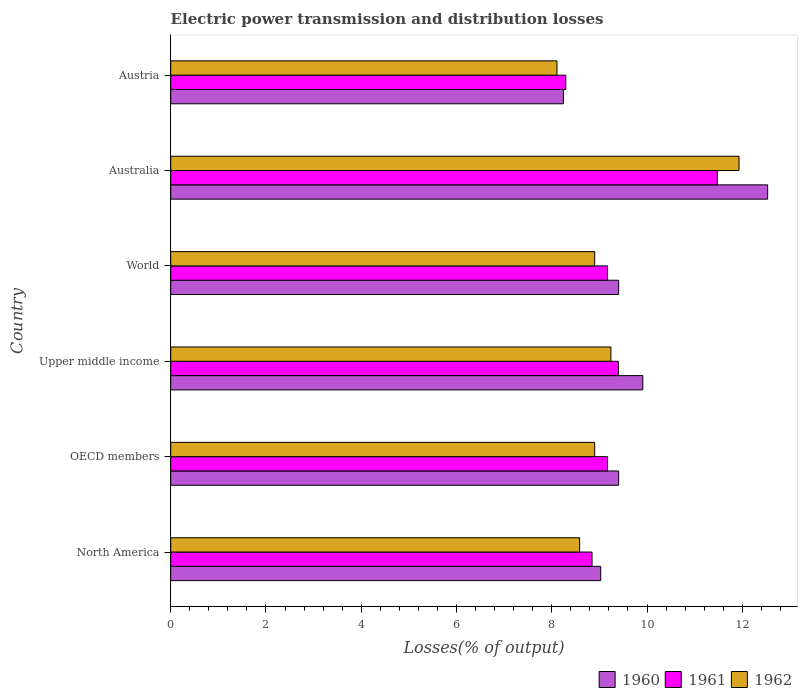Are the number of bars on each tick of the Y-axis equal?
Your response must be concise. Yes. How many bars are there on the 2nd tick from the top?
Make the answer very short. 3. How many bars are there on the 6th tick from the bottom?
Give a very brief answer. 3. What is the label of the 1st group of bars from the top?
Offer a terse response. Austria. What is the electric power transmission and distribution losses in 1961 in World?
Provide a short and direct response. 9.17. Across all countries, what is the maximum electric power transmission and distribution losses in 1961?
Provide a short and direct response. 11.48. Across all countries, what is the minimum electric power transmission and distribution losses in 1961?
Provide a short and direct response. 8.3. In which country was the electric power transmission and distribution losses in 1962 maximum?
Provide a succinct answer. Australia. In which country was the electric power transmission and distribution losses in 1960 minimum?
Ensure brevity in your answer.  Austria. What is the total electric power transmission and distribution losses in 1960 in the graph?
Provide a short and direct response. 58.52. What is the difference between the electric power transmission and distribution losses in 1960 in Austria and that in Upper middle income?
Ensure brevity in your answer.  -1.67. What is the difference between the electric power transmission and distribution losses in 1960 in Australia and the electric power transmission and distribution losses in 1961 in Austria?
Your answer should be very brief. 4.24. What is the average electric power transmission and distribution losses in 1962 per country?
Offer a very short reply. 9.28. What is the difference between the electric power transmission and distribution losses in 1962 and electric power transmission and distribution losses in 1961 in Austria?
Provide a succinct answer. -0.19. What is the ratio of the electric power transmission and distribution losses in 1961 in Australia to that in Austria?
Keep it short and to the point. 1.38. Is the difference between the electric power transmission and distribution losses in 1962 in Austria and OECD members greater than the difference between the electric power transmission and distribution losses in 1961 in Austria and OECD members?
Offer a terse response. Yes. What is the difference between the highest and the second highest electric power transmission and distribution losses in 1960?
Your response must be concise. 2.62. What is the difference between the highest and the lowest electric power transmission and distribution losses in 1962?
Offer a terse response. 3.82. Is the sum of the electric power transmission and distribution losses in 1962 in Australia and OECD members greater than the maximum electric power transmission and distribution losses in 1961 across all countries?
Provide a succinct answer. Yes. What does the 1st bar from the top in North America represents?
Your response must be concise. 1962. Does the graph contain any zero values?
Your response must be concise. No. Where does the legend appear in the graph?
Ensure brevity in your answer.  Bottom right. How many legend labels are there?
Offer a very short reply. 3. What is the title of the graph?
Keep it short and to the point. Electric power transmission and distribution losses. Does "1982" appear as one of the legend labels in the graph?
Make the answer very short. No. What is the label or title of the X-axis?
Give a very brief answer. Losses(% of output). What is the label or title of the Y-axis?
Your answer should be compact. Country. What is the Losses(% of output) in 1960 in North America?
Your answer should be very brief. 9.03. What is the Losses(% of output) in 1961 in North America?
Ensure brevity in your answer.  8.85. What is the Losses(% of output) in 1962 in North America?
Offer a terse response. 8.59. What is the Losses(% of output) of 1960 in OECD members?
Provide a short and direct response. 9.4. What is the Losses(% of output) of 1961 in OECD members?
Provide a short and direct response. 9.17. What is the Losses(% of output) of 1962 in OECD members?
Your response must be concise. 8.9. What is the Losses(% of output) in 1960 in Upper middle income?
Provide a short and direct response. 9.91. What is the Losses(% of output) of 1961 in Upper middle income?
Offer a very short reply. 9.4. What is the Losses(% of output) in 1962 in Upper middle income?
Give a very brief answer. 9.24. What is the Losses(% of output) in 1960 in World?
Provide a succinct answer. 9.4. What is the Losses(% of output) in 1961 in World?
Your answer should be compact. 9.17. What is the Losses(% of output) in 1962 in World?
Provide a short and direct response. 8.9. What is the Losses(% of output) in 1960 in Australia?
Provide a succinct answer. 12.53. What is the Losses(% of output) in 1961 in Australia?
Provide a succinct answer. 11.48. What is the Losses(% of output) of 1962 in Australia?
Ensure brevity in your answer.  11.93. What is the Losses(% of output) in 1960 in Austria?
Your answer should be very brief. 8.24. What is the Losses(% of output) in 1961 in Austria?
Give a very brief answer. 8.3. What is the Losses(% of output) in 1962 in Austria?
Offer a very short reply. 8.11. Across all countries, what is the maximum Losses(% of output) in 1960?
Provide a succinct answer. 12.53. Across all countries, what is the maximum Losses(% of output) in 1961?
Offer a terse response. 11.48. Across all countries, what is the maximum Losses(% of output) in 1962?
Keep it short and to the point. 11.93. Across all countries, what is the minimum Losses(% of output) in 1960?
Your answer should be very brief. 8.24. Across all countries, what is the minimum Losses(% of output) in 1961?
Your response must be concise. 8.3. Across all countries, what is the minimum Losses(% of output) of 1962?
Your response must be concise. 8.11. What is the total Losses(% of output) in 1960 in the graph?
Provide a short and direct response. 58.52. What is the total Losses(% of output) of 1961 in the graph?
Your answer should be compact. 56.36. What is the total Losses(% of output) in 1962 in the graph?
Your answer should be very brief. 55.67. What is the difference between the Losses(% of output) of 1960 in North America and that in OECD members?
Give a very brief answer. -0.38. What is the difference between the Losses(% of output) in 1961 in North America and that in OECD members?
Ensure brevity in your answer.  -0.33. What is the difference between the Losses(% of output) in 1962 in North America and that in OECD members?
Offer a very short reply. -0.32. What is the difference between the Losses(% of output) of 1960 in North America and that in Upper middle income?
Provide a succinct answer. -0.88. What is the difference between the Losses(% of output) in 1961 in North America and that in Upper middle income?
Your response must be concise. -0.55. What is the difference between the Losses(% of output) in 1962 in North America and that in Upper middle income?
Provide a short and direct response. -0.66. What is the difference between the Losses(% of output) in 1960 in North America and that in World?
Offer a terse response. -0.38. What is the difference between the Losses(% of output) of 1961 in North America and that in World?
Your answer should be compact. -0.33. What is the difference between the Losses(% of output) in 1962 in North America and that in World?
Offer a very short reply. -0.32. What is the difference between the Losses(% of output) in 1960 in North America and that in Australia?
Keep it short and to the point. -3.5. What is the difference between the Losses(% of output) in 1961 in North America and that in Australia?
Give a very brief answer. -2.63. What is the difference between the Losses(% of output) in 1962 in North America and that in Australia?
Provide a short and direct response. -3.35. What is the difference between the Losses(% of output) of 1960 in North America and that in Austria?
Your answer should be compact. 0.78. What is the difference between the Losses(% of output) of 1961 in North America and that in Austria?
Keep it short and to the point. 0.55. What is the difference between the Losses(% of output) of 1962 in North America and that in Austria?
Give a very brief answer. 0.48. What is the difference between the Losses(% of output) of 1960 in OECD members and that in Upper middle income?
Make the answer very short. -0.51. What is the difference between the Losses(% of output) of 1961 in OECD members and that in Upper middle income?
Ensure brevity in your answer.  -0.23. What is the difference between the Losses(% of output) of 1962 in OECD members and that in Upper middle income?
Your answer should be very brief. -0.34. What is the difference between the Losses(% of output) in 1962 in OECD members and that in World?
Provide a succinct answer. 0. What is the difference between the Losses(% of output) of 1960 in OECD members and that in Australia?
Your answer should be very brief. -3.13. What is the difference between the Losses(% of output) in 1961 in OECD members and that in Australia?
Your response must be concise. -2.3. What is the difference between the Losses(% of output) in 1962 in OECD members and that in Australia?
Your response must be concise. -3.03. What is the difference between the Losses(% of output) in 1960 in OECD members and that in Austria?
Your response must be concise. 1.16. What is the difference between the Losses(% of output) of 1961 in OECD members and that in Austria?
Ensure brevity in your answer.  0.88. What is the difference between the Losses(% of output) in 1962 in OECD members and that in Austria?
Provide a succinct answer. 0.79. What is the difference between the Losses(% of output) in 1960 in Upper middle income and that in World?
Provide a short and direct response. 0.51. What is the difference between the Losses(% of output) of 1961 in Upper middle income and that in World?
Your answer should be very brief. 0.23. What is the difference between the Losses(% of output) in 1962 in Upper middle income and that in World?
Offer a very short reply. 0.34. What is the difference between the Losses(% of output) in 1960 in Upper middle income and that in Australia?
Give a very brief answer. -2.62. What is the difference between the Losses(% of output) in 1961 in Upper middle income and that in Australia?
Offer a terse response. -2.08. What is the difference between the Losses(% of output) in 1962 in Upper middle income and that in Australia?
Keep it short and to the point. -2.69. What is the difference between the Losses(% of output) in 1960 in Upper middle income and that in Austria?
Offer a very short reply. 1.67. What is the difference between the Losses(% of output) in 1961 in Upper middle income and that in Austria?
Ensure brevity in your answer.  1.1. What is the difference between the Losses(% of output) in 1962 in Upper middle income and that in Austria?
Your response must be concise. 1.13. What is the difference between the Losses(% of output) in 1960 in World and that in Australia?
Provide a succinct answer. -3.13. What is the difference between the Losses(% of output) of 1961 in World and that in Australia?
Ensure brevity in your answer.  -2.3. What is the difference between the Losses(% of output) of 1962 in World and that in Australia?
Provide a succinct answer. -3.03. What is the difference between the Losses(% of output) of 1960 in World and that in Austria?
Your answer should be compact. 1.16. What is the difference between the Losses(% of output) in 1961 in World and that in Austria?
Your answer should be compact. 0.88. What is the difference between the Losses(% of output) in 1962 in World and that in Austria?
Keep it short and to the point. 0.79. What is the difference between the Losses(% of output) of 1960 in Australia and that in Austria?
Ensure brevity in your answer.  4.29. What is the difference between the Losses(% of output) of 1961 in Australia and that in Austria?
Your answer should be very brief. 3.18. What is the difference between the Losses(% of output) in 1962 in Australia and that in Austria?
Ensure brevity in your answer.  3.82. What is the difference between the Losses(% of output) in 1960 in North America and the Losses(% of output) in 1961 in OECD members?
Your answer should be very brief. -0.14. What is the difference between the Losses(% of output) of 1960 in North America and the Losses(% of output) of 1962 in OECD members?
Your answer should be compact. 0.13. What is the difference between the Losses(% of output) in 1961 in North America and the Losses(% of output) in 1962 in OECD members?
Provide a short and direct response. -0.06. What is the difference between the Losses(% of output) of 1960 in North America and the Losses(% of output) of 1961 in Upper middle income?
Offer a very short reply. -0.37. What is the difference between the Losses(% of output) in 1960 in North America and the Losses(% of output) in 1962 in Upper middle income?
Your answer should be very brief. -0.21. What is the difference between the Losses(% of output) in 1961 in North America and the Losses(% of output) in 1962 in Upper middle income?
Give a very brief answer. -0.4. What is the difference between the Losses(% of output) of 1960 in North America and the Losses(% of output) of 1961 in World?
Your response must be concise. -0.14. What is the difference between the Losses(% of output) in 1960 in North America and the Losses(% of output) in 1962 in World?
Your response must be concise. 0.13. What is the difference between the Losses(% of output) in 1961 in North America and the Losses(% of output) in 1962 in World?
Keep it short and to the point. -0.06. What is the difference between the Losses(% of output) in 1960 in North America and the Losses(% of output) in 1961 in Australia?
Offer a very short reply. -2.45. What is the difference between the Losses(% of output) of 1960 in North America and the Losses(% of output) of 1962 in Australia?
Keep it short and to the point. -2.9. What is the difference between the Losses(% of output) of 1961 in North America and the Losses(% of output) of 1962 in Australia?
Your response must be concise. -3.09. What is the difference between the Losses(% of output) of 1960 in North America and the Losses(% of output) of 1961 in Austria?
Your response must be concise. 0.73. What is the difference between the Losses(% of output) in 1960 in North America and the Losses(% of output) in 1962 in Austria?
Offer a very short reply. 0.92. What is the difference between the Losses(% of output) of 1961 in North America and the Losses(% of output) of 1962 in Austria?
Keep it short and to the point. 0.74. What is the difference between the Losses(% of output) in 1960 in OECD members and the Losses(% of output) in 1961 in Upper middle income?
Your answer should be very brief. 0.01. What is the difference between the Losses(% of output) in 1960 in OECD members and the Losses(% of output) in 1962 in Upper middle income?
Keep it short and to the point. 0.16. What is the difference between the Losses(% of output) in 1961 in OECD members and the Losses(% of output) in 1962 in Upper middle income?
Provide a succinct answer. -0.07. What is the difference between the Losses(% of output) of 1960 in OECD members and the Losses(% of output) of 1961 in World?
Offer a very short reply. 0.23. What is the difference between the Losses(% of output) in 1960 in OECD members and the Losses(% of output) in 1962 in World?
Your answer should be compact. 0.5. What is the difference between the Losses(% of output) of 1961 in OECD members and the Losses(% of output) of 1962 in World?
Ensure brevity in your answer.  0.27. What is the difference between the Losses(% of output) of 1960 in OECD members and the Losses(% of output) of 1961 in Australia?
Offer a very short reply. -2.07. What is the difference between the Losses(% of output) in 1960 in OECD members and the Losses(% of output) in 1962 in Australia?
Keep it short and to the point. -2.53. What is the difference between the Losses(% of output) of 1961 in OECD members and the Losses(% of output) of 1962 in Australia?
Your answer should be very brief. -2.76. What is the difference between the Losses(% of output) in 1960 in OECD members and the Losses(% of output) in 1961 in Austria?
Your answer should be very brief. 1.11. What is the difference between the Losses(% of output) in 1960 in OECD members and the Losses(% of output) in 1962 in Austria?
Your answer should be very brief. 1.29. What is the difference between the Losses(% of output) in 1961 in OECD members and the Losses(% of output) in 1962 in Austria?
Your response must be concise. 1.06. What is the difference between the Losses(% of output) of 1960 in Upper middle income and the Losses(% of output) of 1961 in World?
Ensure brevity in your answer.  0.74. What is the difference between the Losses(% of output) of 1960 in Upper middle income and the Losses(% of output) of 1962 in World?
Your answer should be compact. 1.01. What is the difference between the Losses(% of output) in 1961 in Upper middle income and the Losses(% of output) in 1962 in World?
Your response must be concise. 0.5. What is the difference between the Losses(% of output) of 1960 in Upper middle income and the Losses(% of output) of 1961 in Australia?
Your answer should be very brief. -1.56. What is the difference between the Losses(% of output) of 1960 in Upper middle income and the Losses(% of output) of 1962 in Australia?
Offer a terse response. -2.02. What is the difference between the Losses(% of output) of 1961 in Upper middle income and the Losses(% of output) of 1962 in Australia?
Offer a very short reply. -2.53. What is the difference between the Losses(% of output) of 1960 in Upper middle income and the Losses(% of output) of 1961 in Austria?
Your answer should be very brief. 1.62. What is the difference between the Losses(% of output) of 1960 in Upper middle income and the Losses(% of output) of 1962 in Austria?
Provide a succinct answer. 1.8. What is the difference between the Losses(% of output) in 1961 in Upper middle income and the Losses(% of output) in 1962 in Austria?
Your answer should be compact. 1.29. What is the difference between the Losses(% of output) in 1960 in World and the Losses(% of output) in 1961 in Australia?
Your answer should be compact. -2.07. What is the difference between the Losses(% of output) of 1960 in World and the Losses(% of output) of 1962 in Australia?
Your response must be concise. -2.53. What is the difference between the Losses(% of output) of 1961 in World and the Losses(% of output) of 1962 in Australia?
Your response must be concise. -2.76. What is the difference between the Losses(% of output) in 1960 in World and the Losses(% of output) in 1961 in Austria?
Provide a succinct answer. 1.11. What is the difference between the Losses(% of output) in 1960 in World and the Losses(% of output) in 1962 in Austria?
Offer a very short reply. 1.29. What is the difference between the Losses(% of output) in 1961 in World and the Losses(% of output) in 1962 in Austria?
Offer a very short reply. 1.06. What is the difference between the Losses(% of output) of 1960 in Australia and the Losses(% of output) of 1961 in Austria?
Your response must be concise. 4.24. What is the difference between the Losses(% of output) of 1960 in Australia and the Losses(% of output) of 1962 in Austria?
Your answer should be very brief. 4.42. What is the difference between the Losses(% of output) of 1961 in Australia and the Losses(% of output) of 1962 in Austria?
Your answer should be compact. 3.37. What is the average Losses(% of output) of 1960 per country?
Provide a short and direct response. 9.75. What is the average Losses(% of output) of 1961 per country?
Your response must be concise. 9.39. What is the average Losses(% of output) of 1962 per country?
Give a very brief answer. 9.28. What is the difference between the Losses(% of output) of 1960 and Losses(% of output) of 1961 in North America?
Ensure brevity in your answer.  0.18. What is the difference between the Losses(% of output) of 1960 and Losses(% of output) of 1962 in North America?
Offer a very short reply. 0.44. What is the difference between the Losses(% of output) in 1961 and Losses(% of output) in 1962 in North America?
Offer a terse response. 0.26. What is the difference between the Losses(% of output) of 1960 and Losses(% of output) of 1961 in OECD members?
Ensure brevity in your answer.  0.23. What is the difference between the Losses(% of output) of 1960 and Losses(% of output) of 1962 in OECD members?
Offer a very short reply. 0.5. What is the difference between the Losses(% of output) in 1961 and Losses(% of output) in 1962 in OECD members?
Make the answer very short. 0.27. What is the difference between the Losses(% of output) in 1960 and Losses(% of output) in 1961 in Upper middle income?
Keep it short and to the point. 0.51. What is the difference between the Losses(% of output) of 1960 and Losses(% of output) of 1962 in Upper middle income?
Make the answer very short. 0.67. What is the difference between the Losses(% of output) of 1961 and Losses(% of output) of 1962 in Upper middle income?
Give a very brief answer. 0.16. What is the difference between the Losses(% of output) in 1960 and Losses(% of output) in 1961 in World?
Offer a terse response. 0.23. What is the difference between the Losses(% of output) of 1960 and Losses(% of output) of 1962 in World?
Provide a succinct answer. 0.5. What is the difference between the Losses(% of output) in 1961 and Losses(% of output) in 1962 in World?
Offer a very short reply. 0.27. What is the difference between the Losses(% of output) of 1960 and Losses(% of output) of 1961 in Australia?
Provide a succinct answer. 1.06. What is the difference between the Losses(% of output) of 1960 and Losses(% of output) of 1962 in Australia?
Make the answer very short. 0.6. What is the difference between the Losses(% of output) in 1961 and Losses(% of output) in 1962 in Australia?
Your answer should be very brief. -0.46. What is the difference between the Losses(% of output) in 1960 and Losses(% of output) in 1961 in Austria?
Keep it short and to the point. -0.05. What is the difference between the Losses(% of output) in 1960 and Losses(% of output) in 1962 in Austria?
Keep it short and to the point. 0.13. What is the difference between the Losses(% of output) in 1961 and Losses(% of output) in 1962 in Austria?
Ensure brevity in your answer.  0.19. What is the ratio of the Losses(% of output) in 1960 in North America to that in OECD members?
Offer a very short reply. 0.96. What is the ratio of the Losses(% of output) of 1961 in North America to that in OECD members?
Make the answer very short. 0.96. What is the ratio of the Losses(% of output) of 1962 in North America to that in OECD members?
Your response must be concise. 0.96. What is the ratio of the Losses(% of output) in 1960 in North America to that in Upper middle income?
Offer a very short reply. 0.91. What is the ratio of the Losses(% of output) of 1961 in North America to that in Upper middle income?
Your answer should be compact. 0.94. What is the ratio of the Losses(% of output) of 1962 in North America to that in Upper middle income?
Provide a short and direct response. 0.93. What is the ratio of the Losses(% of output) of 1960 in North America to that in World?
Your response must be concise. 0.96. What is the ratio of the Losses(% of output) in 1961 in North America to that in World?
Ensure brevity in your answer.  0.96. What is the ratio of the Losses(% of output) in 1962 in North America to that in World?
Your answer should be very brief. 0.96. What is the ratio of the Losses(% of output) of 1960 in North America to that in Australia?
Offer a terse response. 0.72. What is the ratio of the Losses(% of output) in 1961 in North America to that in Australia?
Offer a very short reply. 0.77. What is the ratio of the Losses(% of output) in 1962 in North America to that in Australia?
Provide a succinct answer. 0.72. What is the ratio of the Losses(% of output) of 1960 in North America to that in Austria?
Provide a succinct answer. 1.09. What is the ratio of the Losses(% of output) in 1961 in North America to that in Austria?
Ensure brevity in your answer.  1.07. What is the ratio of the Losses(% of output) of 1962 in North America to that in Austria?
Your answer should be compact. 1.06. What is the ratio of the Losses(% of output) of 1960 in OECD members to that in Upper middle income?
Your answer should be compact. 0.95. What is the ratio of the Losses(% of output) of 1961 in OECD members to that in Upper middle income?
Offer a very short reply. 0.98. What is the ratio of the Losses(% of output) of 1962 in OECD members to that in Upper middle income?
Your response must be concise. 0.96. What is the ratio of the Losses(% of output) in 1960 in OECD members to that in World?
Provide a short and direct response. 1. What is the ratio of the Losses(% of output) in 1961 in OECD members to that in World?
Make the answer very short. 1. What is the ratio of the Losses(% of output) in 1960 in OECD members to that in Australia?
Offer a terse response. 0.75. What is the ratio of the Losses(% of output) of 1961 in OECD members to that in Australia?
Provide a short and direct response. 0.8. What is the ratio of the Losses(% of output) in 1962 in OECD members to that in Australia?
Your answer should be compact. 0.75. What is the ratio of the Losses(% of output) in 1960 in OECD members to that in Austria?
Your response must be concise. 1.14. What is the ratio of the Losses(% of output) of 1961 in OECD members to that in Austria?
Your answer should be very brief. 1.11. What is the ratio of the Losses(% of output) of 1962 in OECD members to that in Austria?
Provide a succinct answer. 1.1. What is the ratio of the Losses(% of output) in 1960 in Upper middle income to that in World?
Offer a very short reply. 1.05. What is the ratio of the Losses(% of output) in 1961 in Upper middle income to that in World?
Give a very brief answer. 1.02. What is the ratio of the Losses(% of output) in 1962 in Upper middle income to that in World?
Provide a succinct answer. 1.04. What is the ratio of the Losses(% of output) in 1960 in Upper middle income to that in Australia?
Give a very brief answer. 0.79. What is the ratio of the Losses(% of output) in 1961 in Upper middle income to that in Australia?
Give a very brief answer. 0.82. What is the ratio of the Losses(% of output) of 1962 in Upper middle income to that in Australia?
Your response must be concise. 0.77. What is the ratio of the Losses(% of output) in 1960 in Upper middle income to that in Austria?
Your answer should be compact. 1.2. What is the ratio of the Losses(% of output) of 1961 in Upper middle income to that in Austria?
Offer a very short reply. 1.13. What is the ratio of the Losses(% of output) of 1962 in Upper middle income to that in Austria?
Your answer should be compact. 1.14. What is the ratio of the Losses(% of output) of 1960 in World to that in Australia?
Your answer should be very brief. 0.75. What is the ratio of the Losses(% of output) in 1961 in World to that in Australia?
Provide a succinct answer. 0.8. What is the ratio of the Losses(% of output) in 1962 in World to that in Australia?
Offer a terse response. 0.75. What is the ratio of the Losses(% of output) in 1960 in World to that in Austria?
Offer a very short reply. 1.14. What is the ratio of the Losses(% of output) in 1961 in World to that in Austria?
Provide a succinct answer. 1.11. What is the ratio of the Losses(% of output) in 1962 in World to that in Austria?
Keep it short and to the point. 1.1. What is the ratio of the Losses(% of output) of 1960 in Australia to that in Austria?
Provide a succinct answer. 1.52. What is the ratio of the Losses(% of output) of 1961 in Australia to that in Austria?
Provide a short and direct response. 1.38. What is the ratio of the Losses(% of output) in 1962 in Australia to that in Austria?
Your response must be concise. 1.47. What is the difference between the highest and the second highest Losses(% of output) in 1960?
Ensure brevity in your answer.  2.62. What is the difference between the highest and the second highest Losses(% of output) in 1961?
Provide a short and direct response. 2.08. What is the difference between the highest and the second highest Losses(% of output) of 1962?
Make the answer very short. 2.69. What is the difference between the highest and the lowest Losses(% of output) in 1960?
Offer a very short reply. 4.29. What is the difference between the highest and the lowest Losses(% of output) of 1961?
Your answer should be compact. 3.18. What is the difference between the highest and the lowest Losses(% of output) of 1962?
Your answer should be very brief. 3.82. 